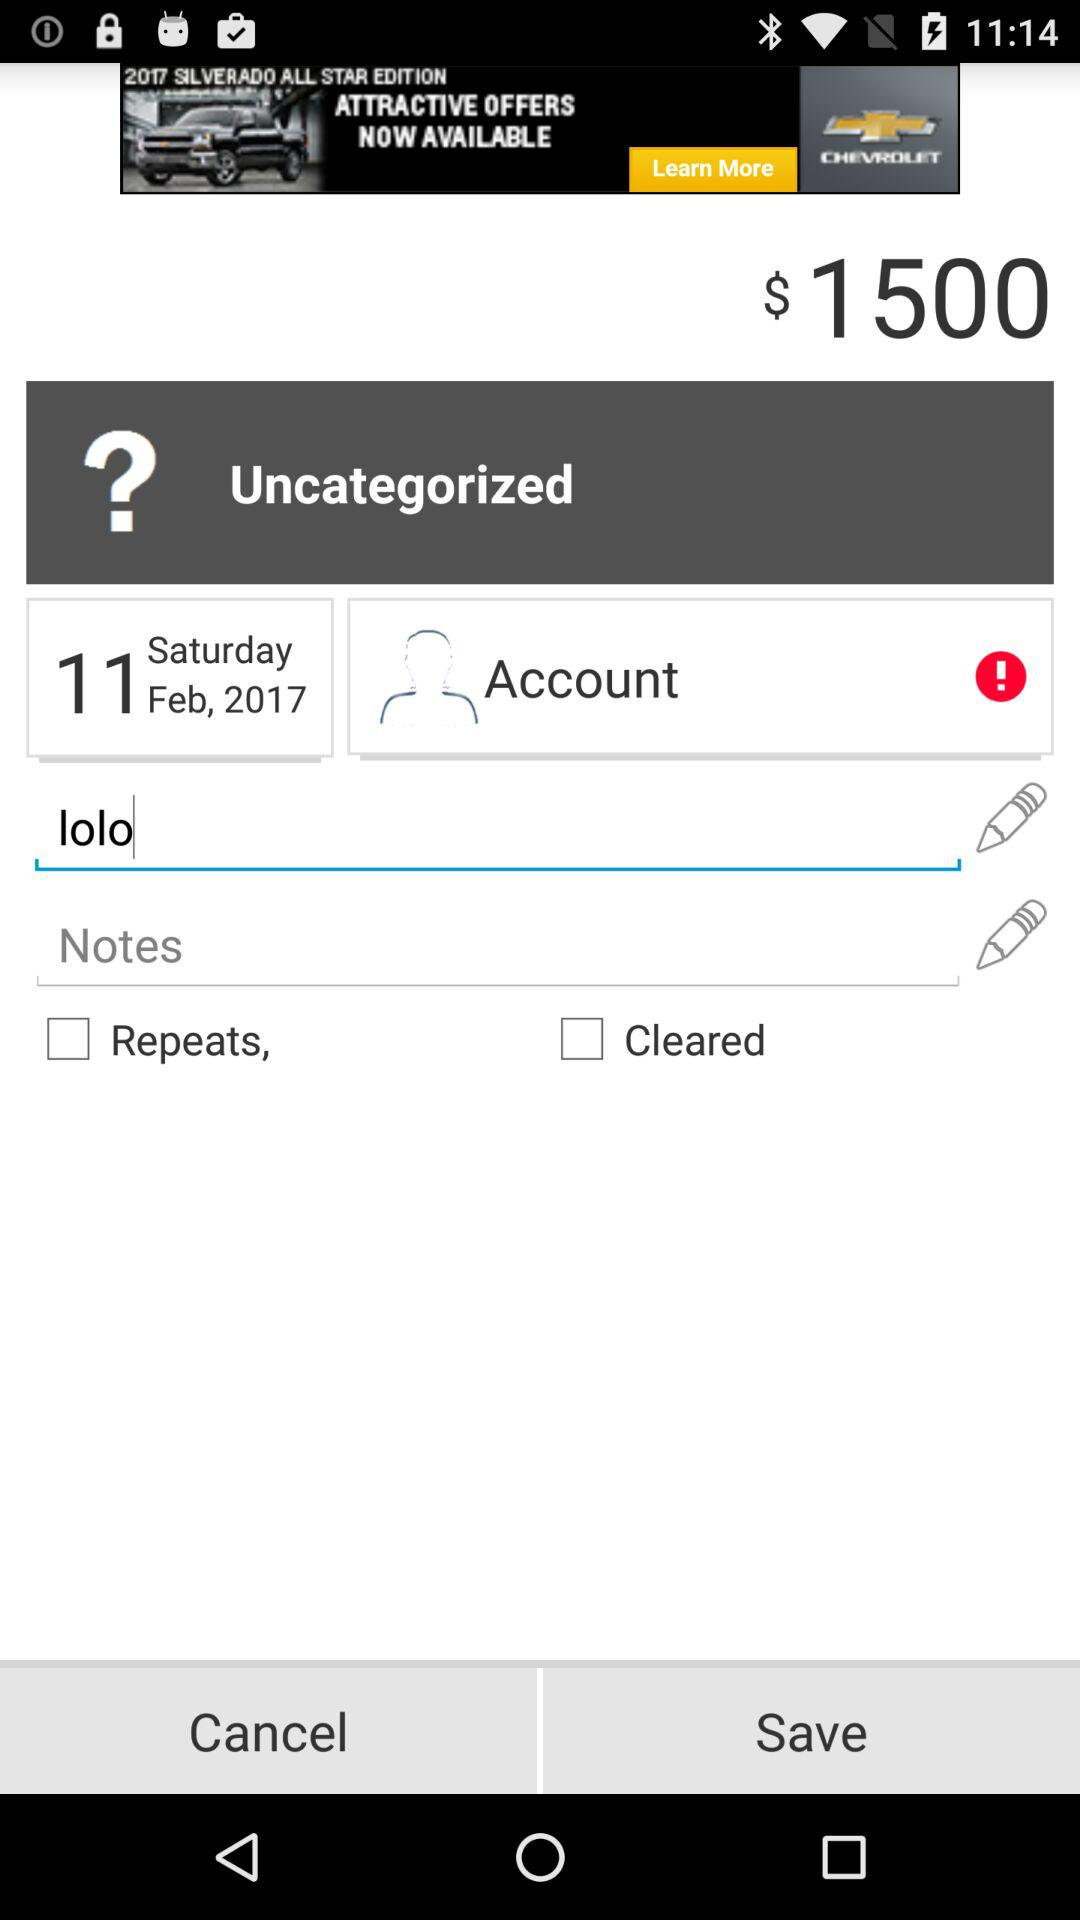What is the date? The date is February 11, 2017. 